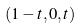<formula> <loc_0><loc_0><loc_500><loc_500>( 1 - t , 0 , t )</formula> 